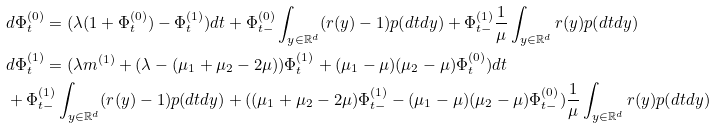<formula> <loc_0><loc_0><loc_500><loc_500>& d \Phi ^ { ( 0 ) } _ { t } = ( \lambda ( 1 + \Phi _ { t } ^ { ( 0 ) } ) - \Phi _ { t } ^ { ( 1 ) } ) d t + \Phi _ { t - } ^ { ( 0 ) } \int _ { y \in \mathbb { R } ^ { d } } ( r ( y ) - 1 ) p ( d t d y ) + \Phi _ { t - } ^ { ( 1 ) } \frac { 1 } { \mu } \int _ { y \in \mathbb { R } ^ { d } } r ( y ) p ( d t d y ) \\ & d \Phi ^ { ( 1 ) } _ { t } = ( \lambda m ^ { ( 1 ) } + ( \lambda - ( \mu _ { 1 } + \mu _ { 2 } - 2 \mu ) ) \Phi ^ { ( 1 ) } _ { t } + ( \mu _ { 1 } - \mu ) ( \mu _ { 2 } - \mu ) \Phi ^ { ( 0 ) } _ { t } ) d t \\ & + \Phi _ { t - } ^ { ( 1 ) } \int _ { y \in \mathbb { R } ^ { d } } ( r ( y ) - 1 ) p ( d t d y ) + ( ( \mu _ { 1 } + \mu _ { 2 } - 2 \mu ) \Phi ^ { ( 1 ) } _ { t - } - ( \mu _ { 1 } - \mu ) ( \mu _ { 2 } - \mu ) \Phi _ { t - } ^ { ( 0 ) } ) \frac { 1 } { \mu } \int _ { y \in \mathbb { R } ^ { d } } r ( y ) p ( d t d y )</formula> 